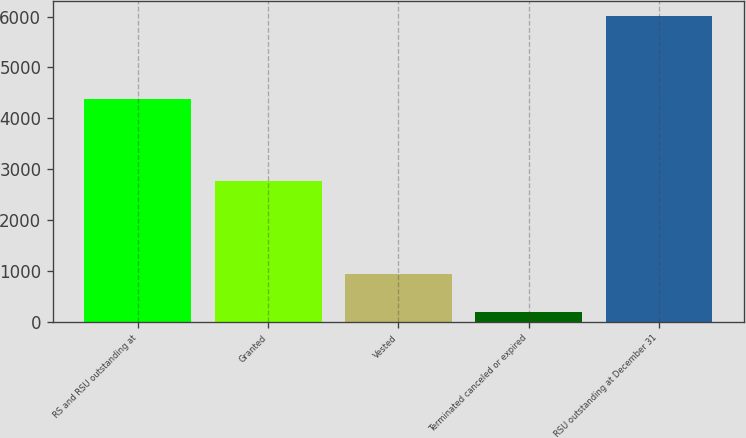Convert chart. <chart><loc_0><loc_0><loc_500><loc_500><bar_chart><fcel>RS and RSU outstanding at<fcel>Granted<fcel>Vested<fcel>Terminated canceled or expired<fcel>RSU outstanding at December 31<nl><fcel>4383<fcel>2761<fcel>938<fcel>190<fcel>6016<nl></chart> 